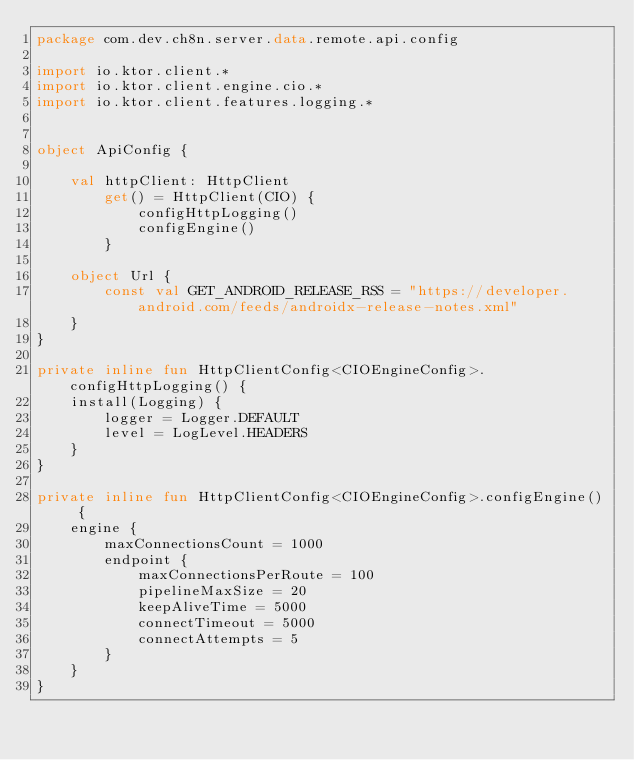<code> <loc_0><loc_0><loc_500><loc_500><_Kotlin_>package com.dev.ch8n.server.data.remote.api.config

import io.ktor.client.*
import io.ktor.client.engine.cio.*
import io.ktor.client.features.logging.*


object ApiConfig {

    val httpClient: HttpClient
        get() = HttpClient(CIO) {
            configHttpLogging()
            configEngine()
        }

    object Url {
        const val GET_ANDROID_RELEASE_RSS = "https://developer.android.com/feeds/androidx-release-notes.xml"
    }
}

private inline fun HttpClientConfig<CIOEngineConfig>.configHttpLogging() {
    install(Logging) {
        logger = Logger.DEFAULT
        level = LogLevel.HEADERS
    }
}

private inline fun HttpClientConfig<CIOEngineConfig>.configEngine() {
    engine {
        maxConnectionsCount = 1000
        endpoint {
            maxConnectionsPerRoute = 100
            pipelineMaxSize = 20
            keepAliveTime = 5000
            connectTimeout = 5000
            connectAttempts = 5
        }
    }
}</code> 